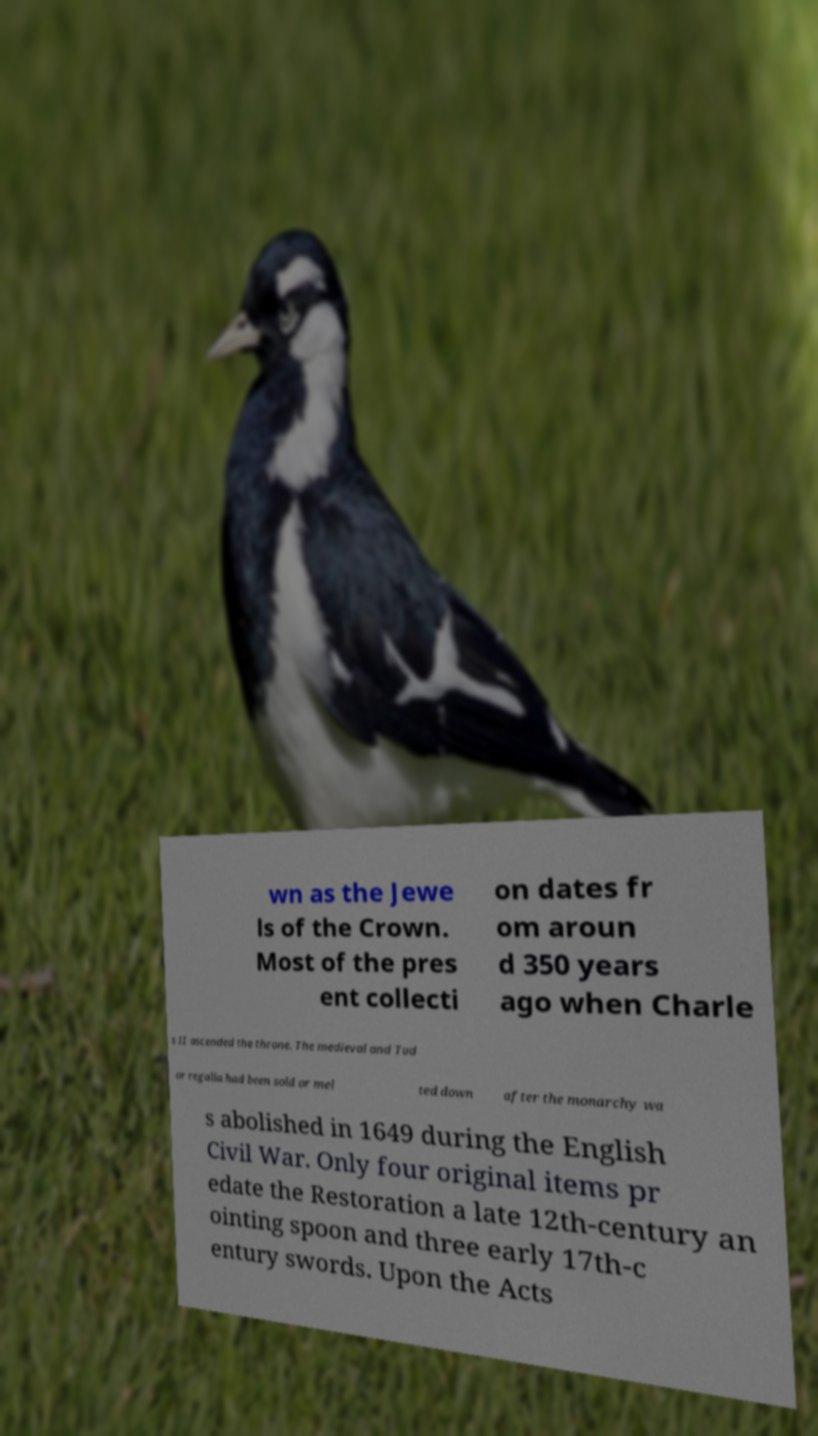There's text embedded in this image that I need extracted. Can you transcribe it verbatim? wn as the Jewe ls of the Crown. Most of the pres ent collecti on dates fr om aroun d 350 years ago when Charle s II ascended the throne. The medieval and Tud or regalia had been sold or mel ted down after the monarchy wa s abolished in 1649 during the English Civil War. Only four original items pr edate the Restoration a late 12th-century an ointing spoon and three early 17th-c entury swords. Upon the Acts 